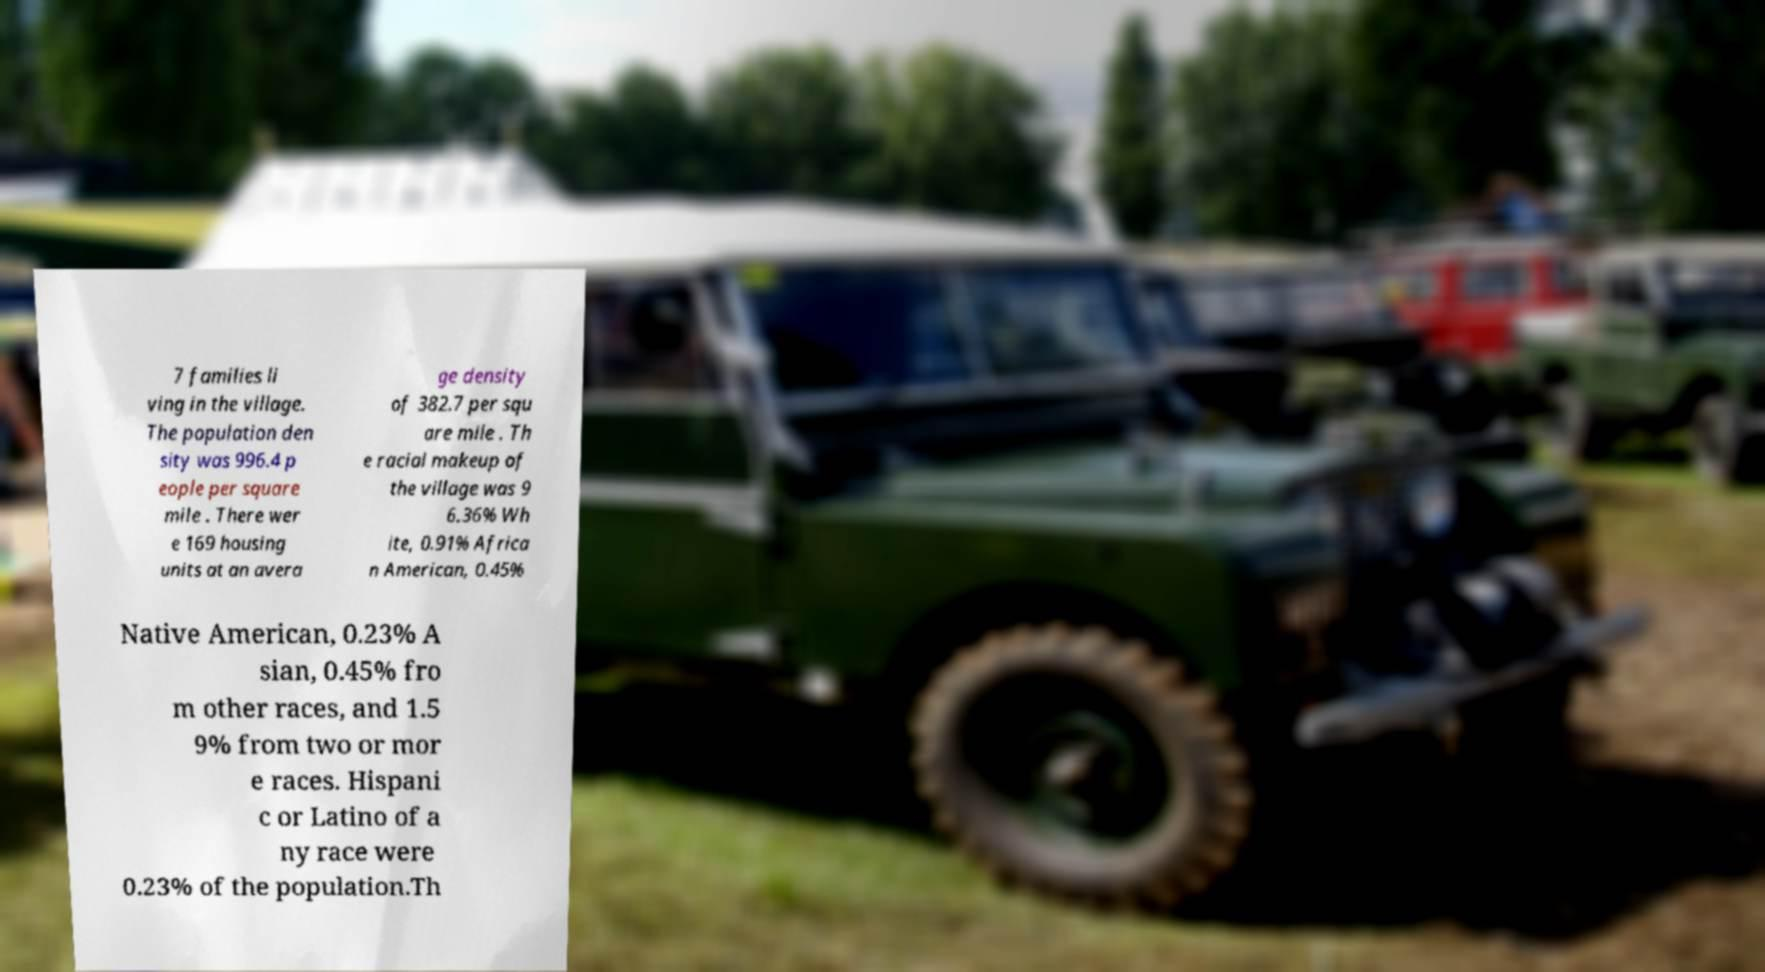There's text embedded in this image that I need extracted. Can you transcribe it verbatim? 7 families li ving in the village. The population den sity was 996.4 p eople per square mile . There wer e 169 housing units at an avera ge density of 382.7 per squ are mile . Th e racial makeup of the village was 9 6.36% Wh ite, 0.91% Africa n American, 0.45% Native American, 0.23% A sian, 0.45% fro m other races, and 1.5 9% from two or mor e races. Hispani c or Latino of a ny race were 0.23% of the population.Th 